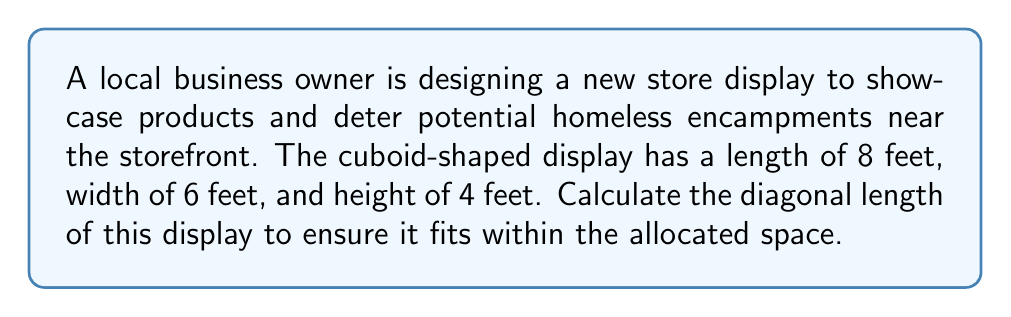Can you answer this question? To find the diagonal length of a cuboid, we can use the three-dimensional extension of the Pythagorean theorem. Let's approach this step-by-step:

1) Let $l$, $w$, and $h$ represent the length, width, and height of the cuboid respectively.
   $l = 8$ feet, $w = 6$ feet, $h = 4$ feet

2) The formula for the diagonal length $d$ of a cuboid is:

   $$d = \sqrt{l^2 + w^2 + h^2}$$

3) Substituting our values:

   $$d = \sqrt{8^2 + 6^2 + 4^2}$$

4) Simplify the squares:

   $$d = \sqrt{64 + 36 + 16}$$

5) Add the values under the square root:

   $$d = \sqrt{116}$$

6) Simplify the square root:

   $$d = 2\sqrt{29}$$ feet

[asy]
import three;

size(200);
currentprojection=perspective(6,3,2);

triple A=(0,0,0), B=(8,0,0), C=(8,6,0), D=(0,6,0), E=(0,0,4), F=(8,0,4), G=(8,6,4), H=(0,6,4);

draw(A--B--C--D--cycle);
draw(E--F--G--H--cycle);
draw(A--E);
draw(B--F);
draw(C--G);
draw(D--H);

draw(A--G,red);

label("A",A,SW);
label("G",G,NE);

[/asy]

The red line in the diagram represents the diagonal of the cuboid.
Answer: $2\sqrt{29}$ feet 